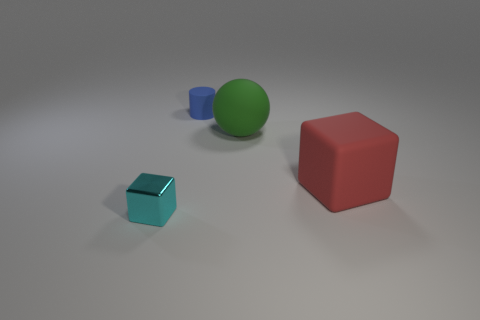There is another thing that is the same size as the red matte object; what material is it?
Ensure brevity in your answer.  Rubber. What material is the tiny thing behind the block in front of the red rubber thing made of?
Your answer should be compact. Rubber. Does the thing that is in front of the red rubber cube have the same shape as the big red object?
Your response must be concise. Yes. There is a big ball that is the same material as the small blue thing; what color is it?
Keep it short and to the point. Green. There is a cube that is to the left of the tiny cylinder; what is it made of?
Keep it short and to the point. Metal. There is a red matte object; is it the same shape as the small object in front of the big cube?
Your answer should be compact. Yes. There is a object that is to the left of the big green sphere and behind the cyan metallic block; what is its material?
Offer a terse response. Rubber. What is the color of the rubber thing that is the same size as the rubber ball?
Provide a short and direct response. Red. Is the material of the small blue cylinder the same as the large red object that is in front of the green rubber thing?
Ensure brevity in your answer.  Yes. There is a big rubber thing that is behind the big object right of the large green rubber sphere; are there any rubber objects that are behind it?
Provide a succinct answer. Yes. 